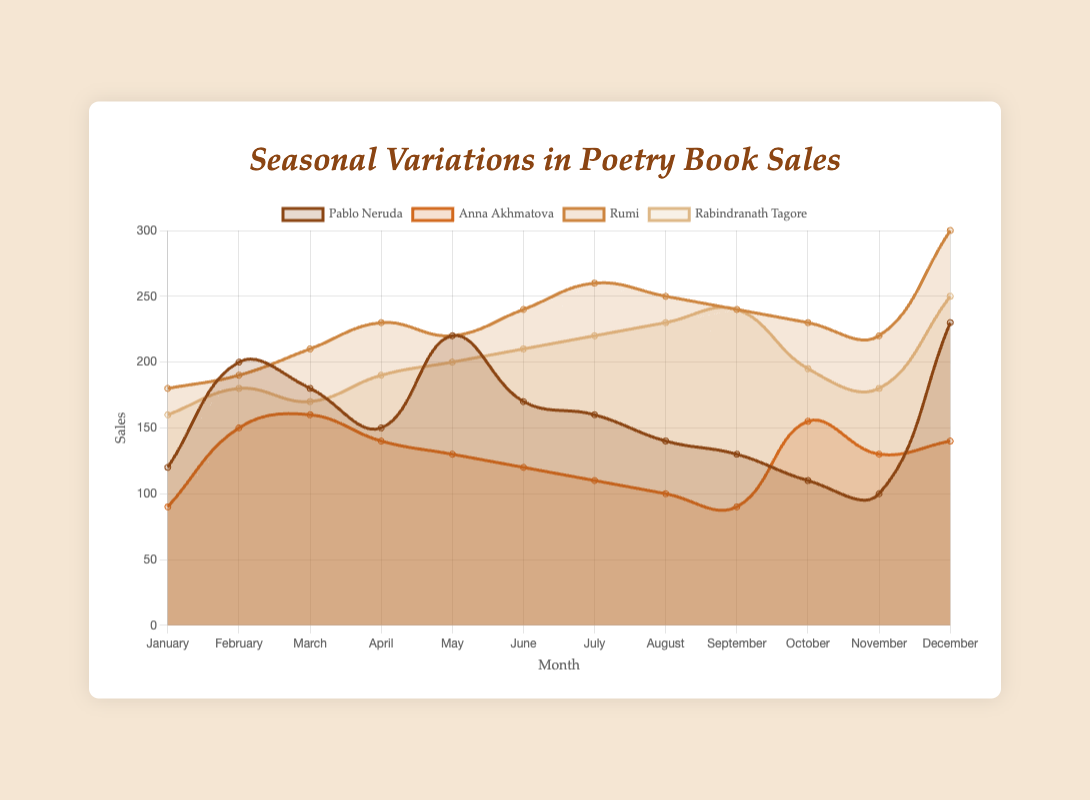Which author has the highest sales in December? Look at the data points for December and compare the sales of all authors. Rumi has the highest sales at 300.
Answer: Rumi During which month did Pablo Neruda have the lowest sales? Identify Pablo Neruda's sales for each month and find the minimum. The lowest sales occur in November at 100.
Answer: November What is the average sales for Anna Akhmatova across all months? Sum Anna Akhmatova's sales for all months (90 + 150 + 160 + 140 + 130 + 120 + 110 + 100 + 90 + 155 + 130 + 140 = 1515) and divide by 12 (the number of months). The average is 1515 / 12 = 126.25.
Answer: 126.25 Which author has the most significant sales increase between January and December? Calculate the difference in sales from January to December for each author. Compare these differences to find the largest. Rumi has the most significant increase (300 - 180 = 120).
Answer: Rumi In which month did Rabindranath Tagore have his highest sales, and what was the amount? Check Rabindranath Tagore's sales for each month to find the maximum. The highest sales occur in December at 250.
Answer: December, 250 Which author had the most consistent sales throughout the year? Evaluating consistency means looking at the variation in sales across months. This is subjective but, visually, Pablo Neruda seems relatively consistent compared to others.
Answer: Pablo Neruda In which month did Rumi experience a peak in sales? Identify the highest sales point for Rumi throughout the year. This peak occurs in December at 300.
Answer: December What is the combined total sales for all authors in May? Sum the sales of all authors in May (Pablo Neruda: 220, Anna Akhmatova: 130, Rumi: 220, Rabindranath Tagore: 200), which is 220 + 130 + 220 + 200 = 770.
Answer: 770 Comparing July sales, who sold more books, Pablo Neruda or Rabindranath Tagore? Check the sales numbers for July for both authors, Pablo Neruda (160) and Rabindranath Tagore (220). Rabindranath Tagore sold more.
Answer: Rabindranath Tagore Calculate the difference between maximum and minimum sales for Rumi throughout the year. Identify Rumi's highest (December, 300) and lowest (January, 180) sales. Calculate the difference 300 - 180 = 120.
Answer: 120 